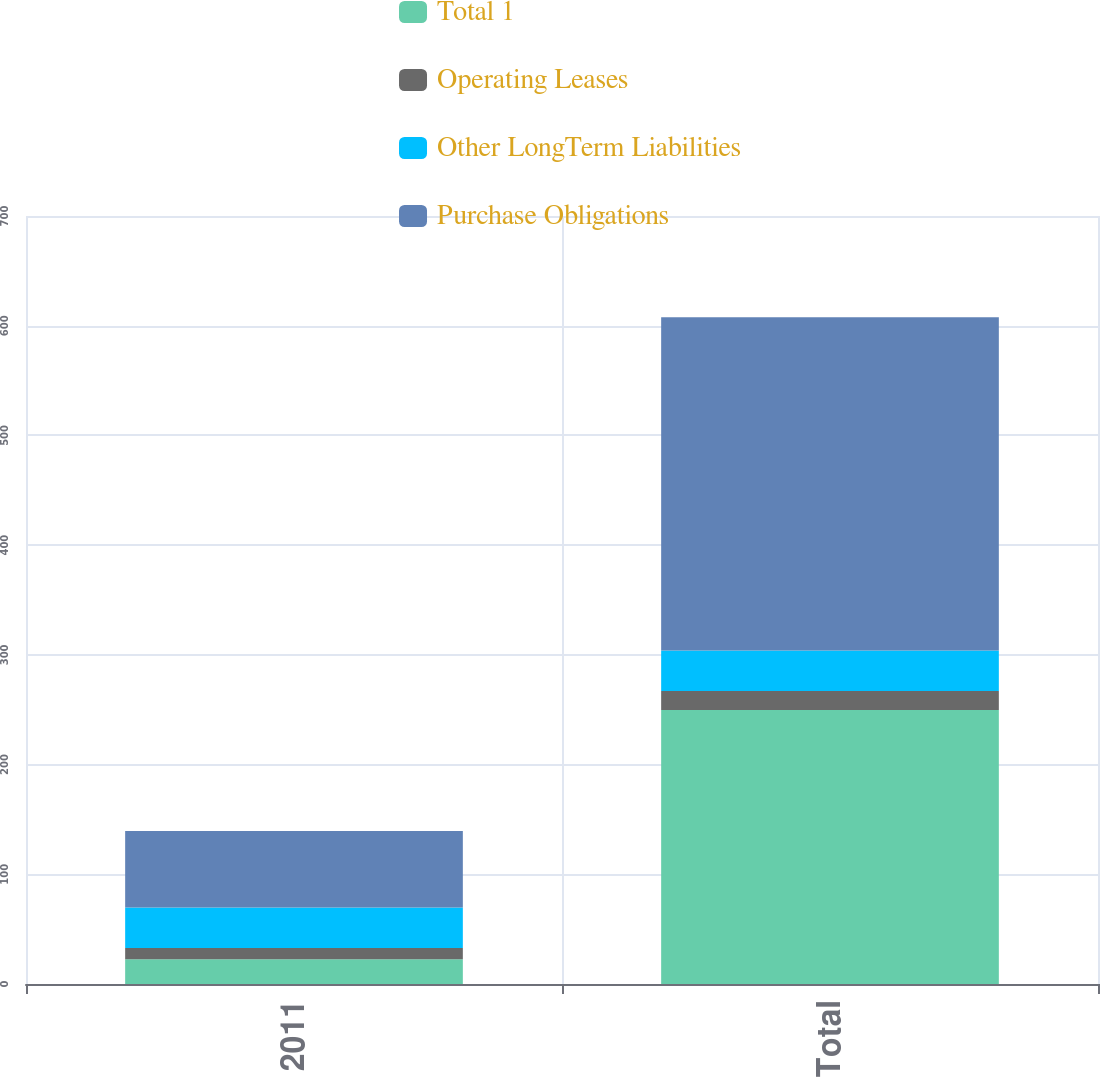<chart> <loc_0><loc_0><loc_500><loc_500><stacked_bar_chart><ecel><fcel>2011<fcel>Total<nl><fcel>Total 1<fcel>22.5<fcel>249.8<nl><fcel>Operating Leases<fcel>10.4<fcel>17.3<nl><fcel>Other LongTerm Liabilities<fcel>36.8<fcel>36.8<nl><fcel>Purchase Obligations<fcel>69.7<fcel>303.9<nl></chart> 